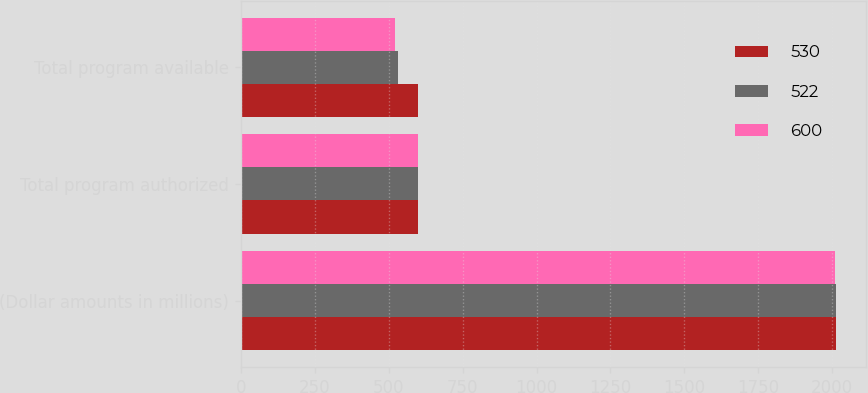Convert chart. <chart><loc_0><loc_0><loc_500><loc_500><stacked_bar_chart><ecel><fcel>(Dollar amounts in millions)<fcel>Total program authorized<fcel>Total program available<nl><fcel>530<fcel>2012<fcel>600<fcel>600<nl><fcel>522<fcel>2011<fcel>600<fcel>530<nl><fcel>600<fcel>2010<fcel>600<fcel>522<nl></chart> 